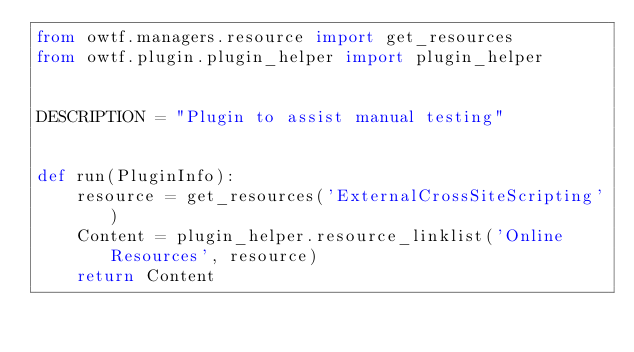Convert code to text. <code><loc_0><loc_0><loc_500><loc_500><_Python_>from owtf.managers.resource import get_resources
from owtf.plugin.plugin_helper import plugin_helper


DESCRIPTION = "Plugin to assist manual testing"


def run(PluginInfo):
    resource = get_resources('ExternalCrossSiteScripting')
    Content = plugin_helper.resource_linklist('Online Resources', resource)
    return Content
</code> 